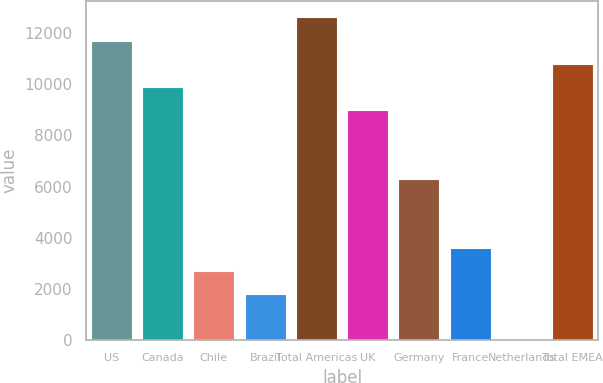Convert chart. <chart><loc_0><loc_0><loc_500><loc_500><bar_chart><fcel>US<fcel>Canada<fcel>Chile<fcel>Brazil<fcel>Total Americas<fcel>UK<fcel>Germany<fcel>France<fcel>Netherlands<fcel>Total EMEA<nl><fcel>11708.5<fcel>9907.5<fcel>2703.5<fcel>1803<fcel>12609<fcel>9007<fcel>6305.5<fcel>3604<fcel>2<fcel>10808<nl></chart> 